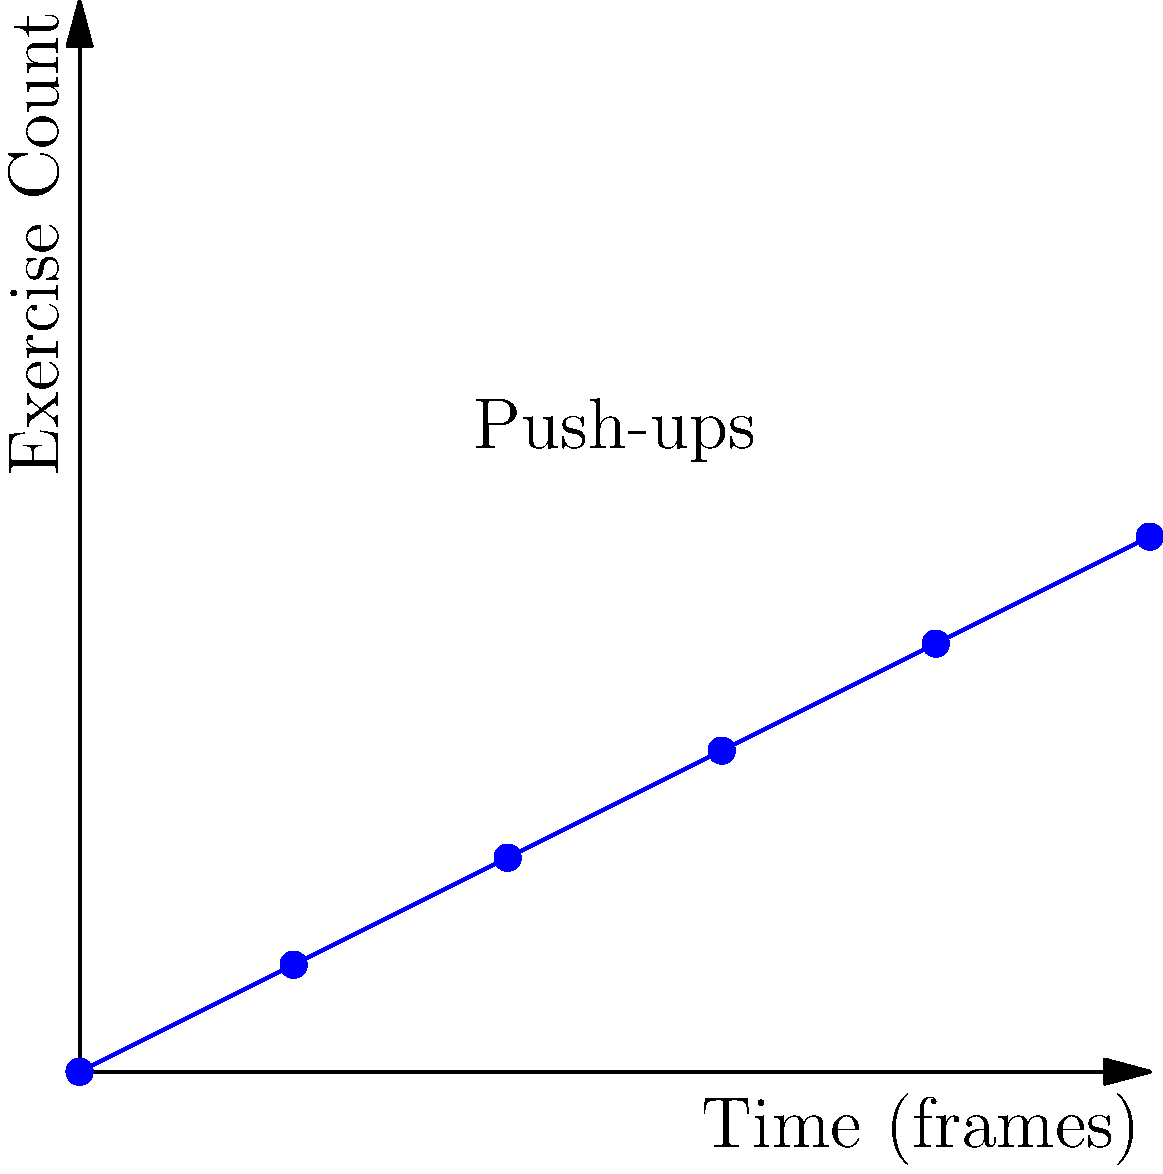Check out this awesome graph, bro! It shows how many push-ups you've done over time during a workout video. If you wanted to make an app that automatically counts your reps, how many push-ups would it have recorded by the 7th frame? Alright, let's break this down like we're analyzing game footage:

1. The x-axis represents time in frames, and the y-axis shows the number of push-ups completed.
2. We can see that the graph increases in steps, with each step representing a completed push-up.
3. The steps occur at frames 2, 4, 6, 8, and 10.
4. We're asked about the 7th frame, which falls between the 3rd and 4th steps.
5. At frame 6, we've completed 3 push-ups.
6. The next increase doesn't happen until frame 8.
7. Therefore, at frame 7, we're still at 3 completed push-ups.

It's like keeping score during a game - you only update the scoreboard when a point is actually scored, not in between plays.
Answer: 3 push-ups 